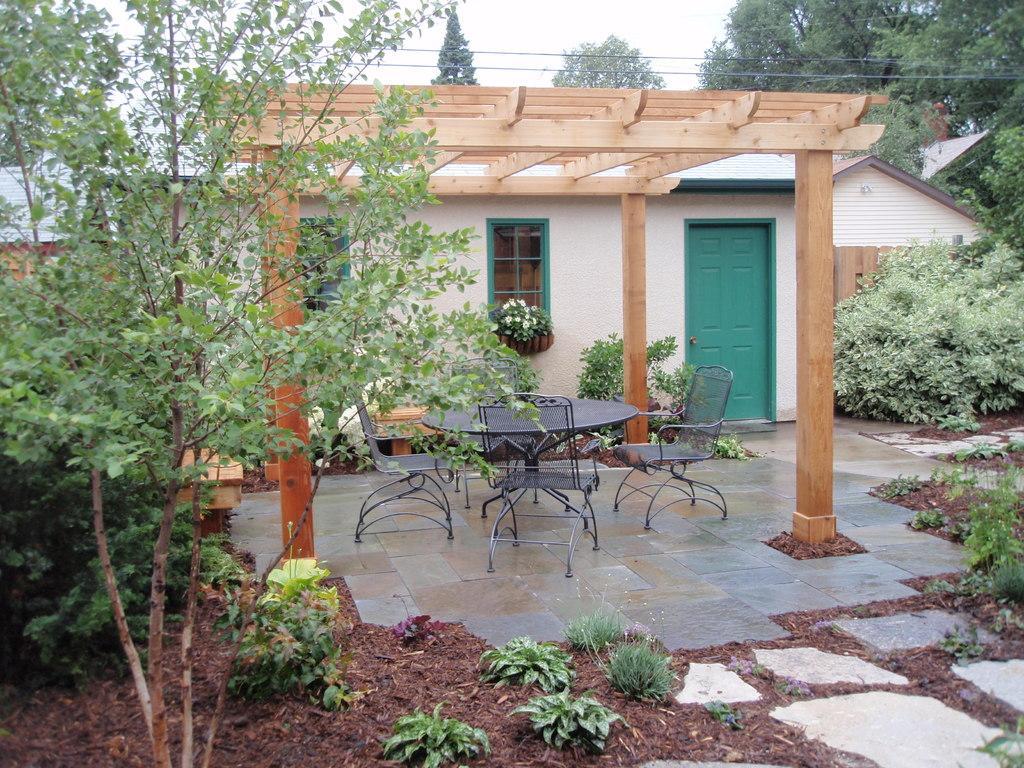Describe this image in one or two sentences. In this picture I can see a house, there are chairs, plants, trees, there is a table, there are cables, and in the background there is sky. 